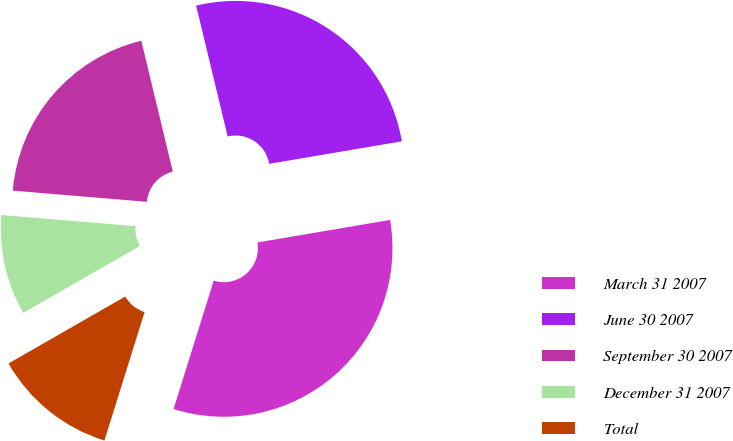<chart> <loc_0><loc_0><loc_500><loc_500><pie_chart><fcel>March 31 2007<fcel>June 30 2007<fcel>September 30 2007<fcel>December 31 2007<fcel>Total<nl><fcel>32.5%<fcel>26.09%<fcel>19.91%<fcel>9.61%<fcel>11.89%<nl></chart> 